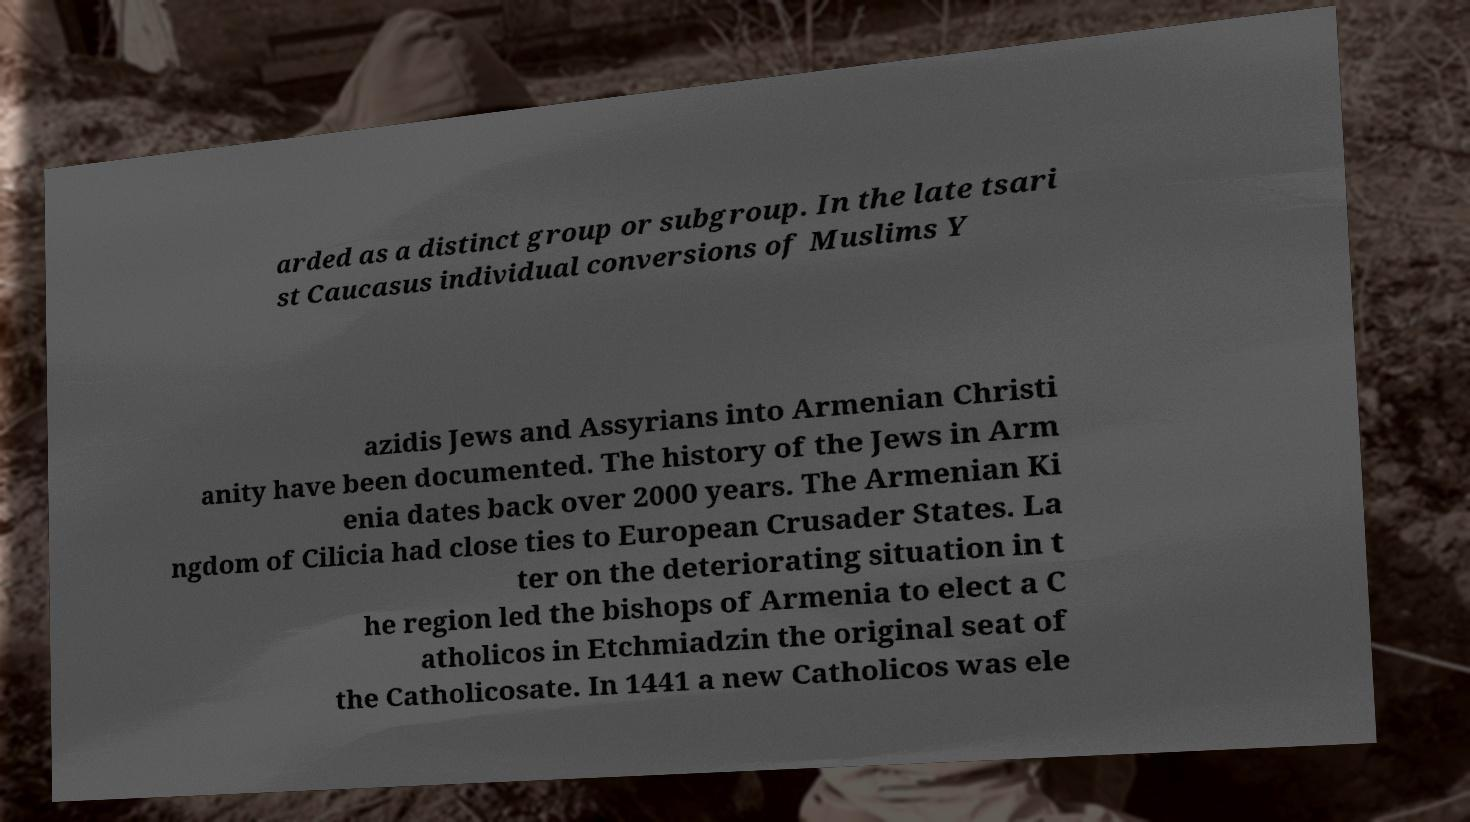There's text embedded in this image that I need extracted. Can you transcribe it verbatim? arded as a distinct group or subgroup. In the late tsari st Caucasus individual conversions of Muslims Y azidis Jews and Assyrians into Armenian Christi anity have been documented. The history of the Jews in Arm enia dates back over 2000 years. The Armenian Ki ngdom of Cilicia had close ties to European Crusader States. La ter on the deteriorating situation in t he region led the bishops of Armenia to elect a C atholicos in Etchmiadzin the original seat of the Catholicosate. In 1441 a new Catholicos was ele 